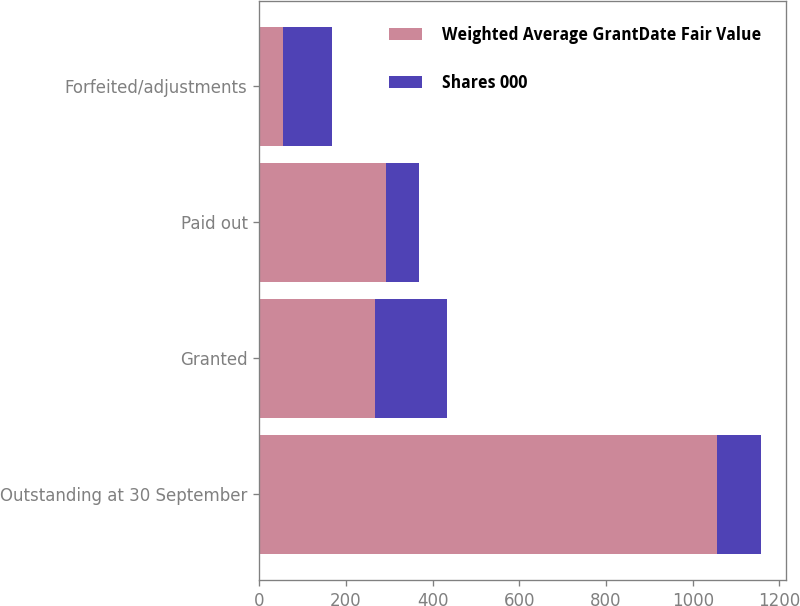Convert chart to OTSL. <chart><loc_0><loc_0><loc_500><loc_500><stacked_bar_chart><ecel><fcel>Outstanding at 30 September<fcel>Granted<fcel>Paid out<fcel>Forfeited/adjustments<nl><fcel>Weighted Average GrantDate Fair Value<fcel>1056<fcel>267<fcel>292<fcel>55<nl><fcel>Shares 000<fcel>102.01<fcel>166.46<fcel>77.07<fcel>113.91<nl></chart> 